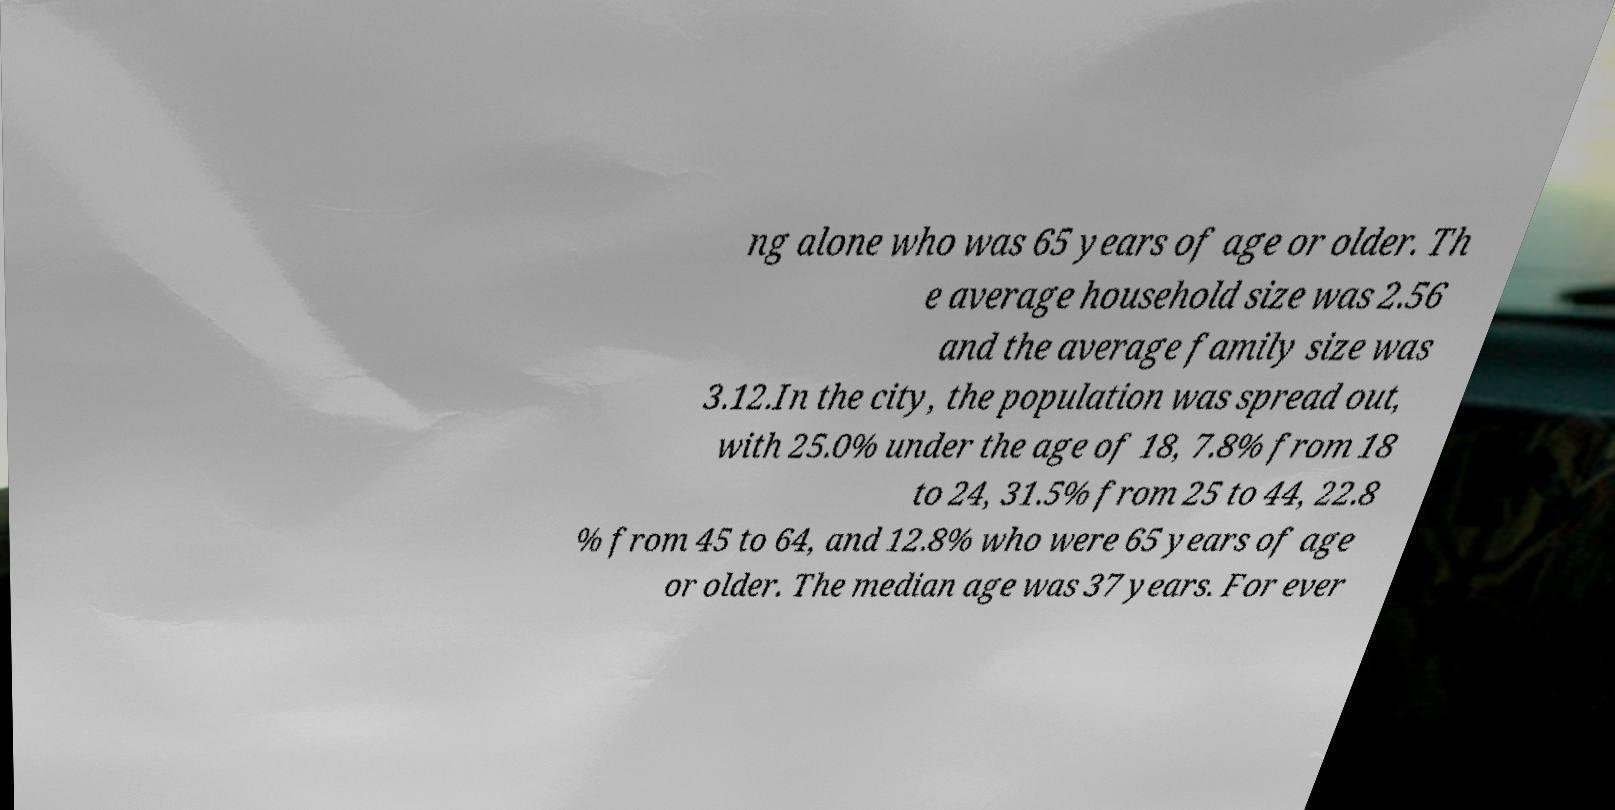What messages or text are displayed in this image? I need them in a readable, typed format. ng alone who was 65 years of age or older. Th e average household size was 2.56 and the average family size was 3.12.In the city, the population was spread out, with 25.0% under the age of 18, 7.8% from 18 to 24, 31.5% from 25 to 44, 22.8 % from 45 to 64, and 12.8% who were 65 years of age or older. The median age was 37 years. For ever 